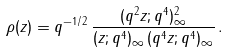Convert formula to latex. <formula><loc_0><loc_0><loc_500><loc_500>\rho ( z ) = q ^ { - 1 / 2 } \, \frac { ( q ^ { 2 } z ; q ^ { 4 } ) _ { \infty } ^ { 2 } } { ( z ; q ^ { 4 } ) _ { \infty } \, ( q ^ { 4 } z ; q ^ { 4 } ) _ { \infty } } \, .</formula> 